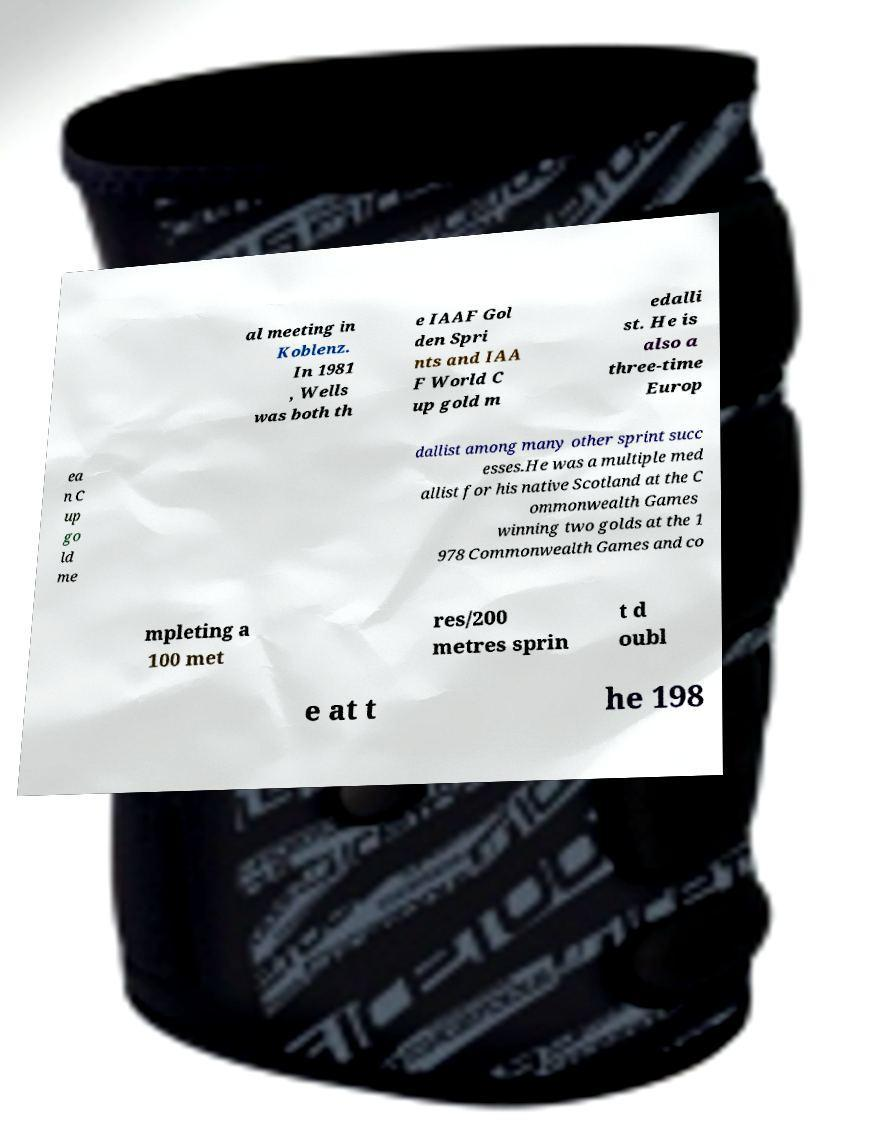Could you assist in decoding the text presented in this image and type it out clearly? al meeting in Koblenz. In 1981 , Wells was both th e IAAF Gol den Spri nts and IAA F World C up gold m edalli st. He is also a three-time Europ ea n C up go ld me dallist among many other sprint succ esses.He was a multiple med allist for his native Scotland at the C ommonwealth Games winning two golds at the 1 978 Commonwealth Games and co mpleting a 100 met res/200 metres sprin t d oubl e at t he 198 